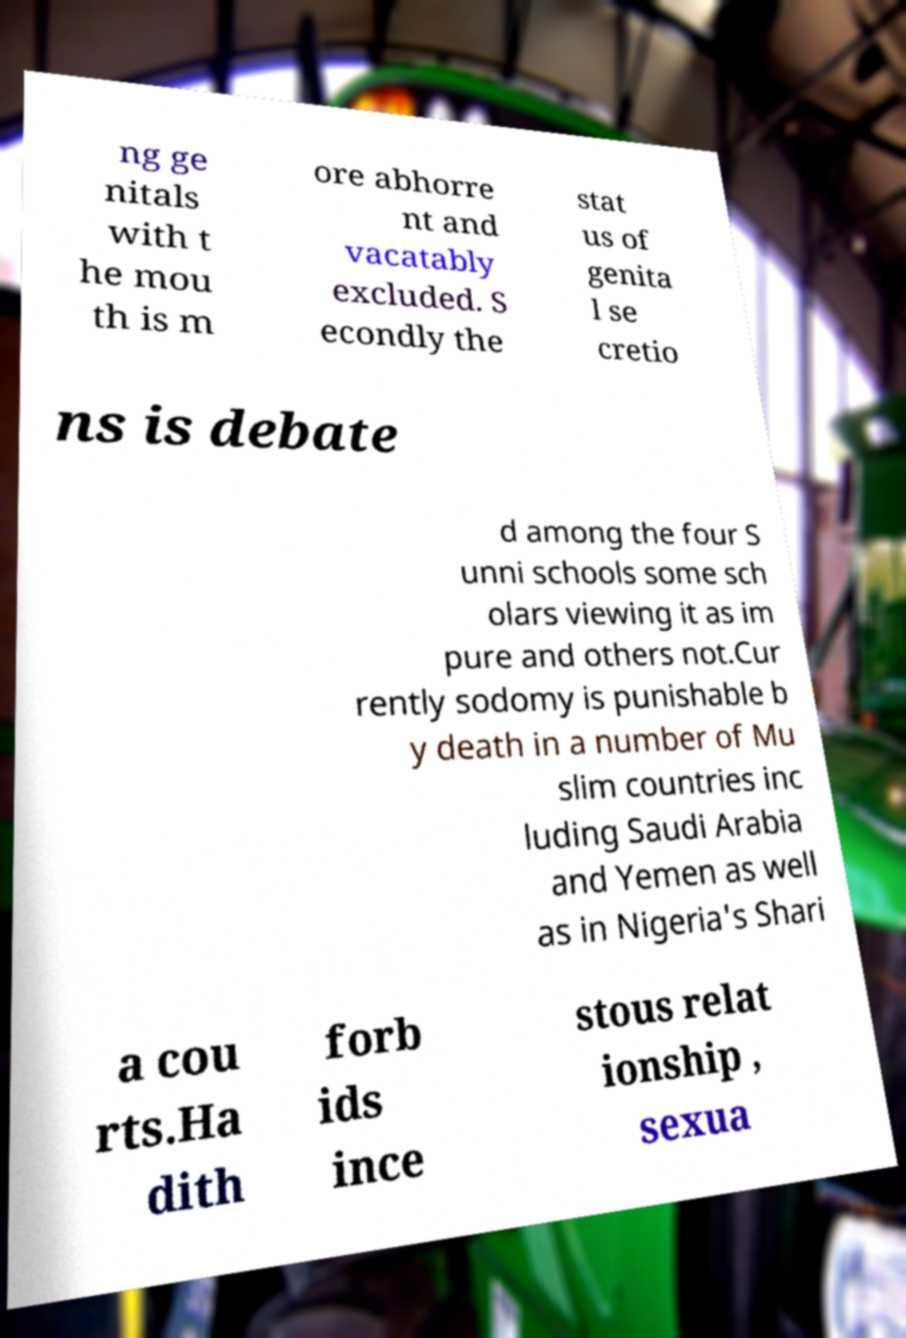There's text embedded in this image that I need extracted. Can you transcribe it verbatim? ng ge nitals with t he mou th is m ore abhorre nt and vacatably excluded. S econdly the stat us of genita l se cretio ns is debate d among the four S unni schools some sch olars viewing it as im pure and others not.Cur rently sodomy is punishable b y death in a number of Mu slim countries inc luding Saudi Arabia and Yemen as well as in Nigeria's Shari a cou rts.Ha dith forb ids ince stous relat ionship , sexua 